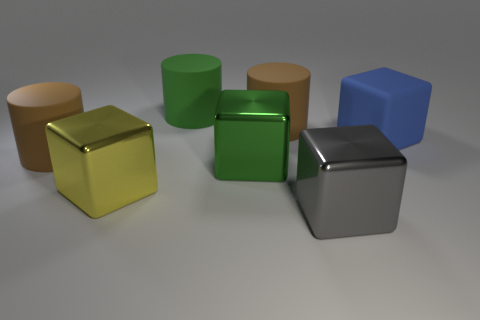Subtract all red blocks. How many brown cylinders are left? 2 Subtract all green blocks. How many blocks are left? 3 Subtract all matte cubes. How many cubes are left? 3 Add 2 blocks. How many objects exist? 9 Subtract all red blocks. Subtract all purple balls. How many blocks are left? 4 Subtract all cylinders. How many objects are left? 4 Subtract all big brown shiny things. Subtract all large rubber cylinders. How many objects are left? 4 Add 6 large blocks. How many large blocks are left? 10 Add 3 brown objects. How many brown objects exist? 5 Subtract 0 red blocks. How many objects are left? 7 